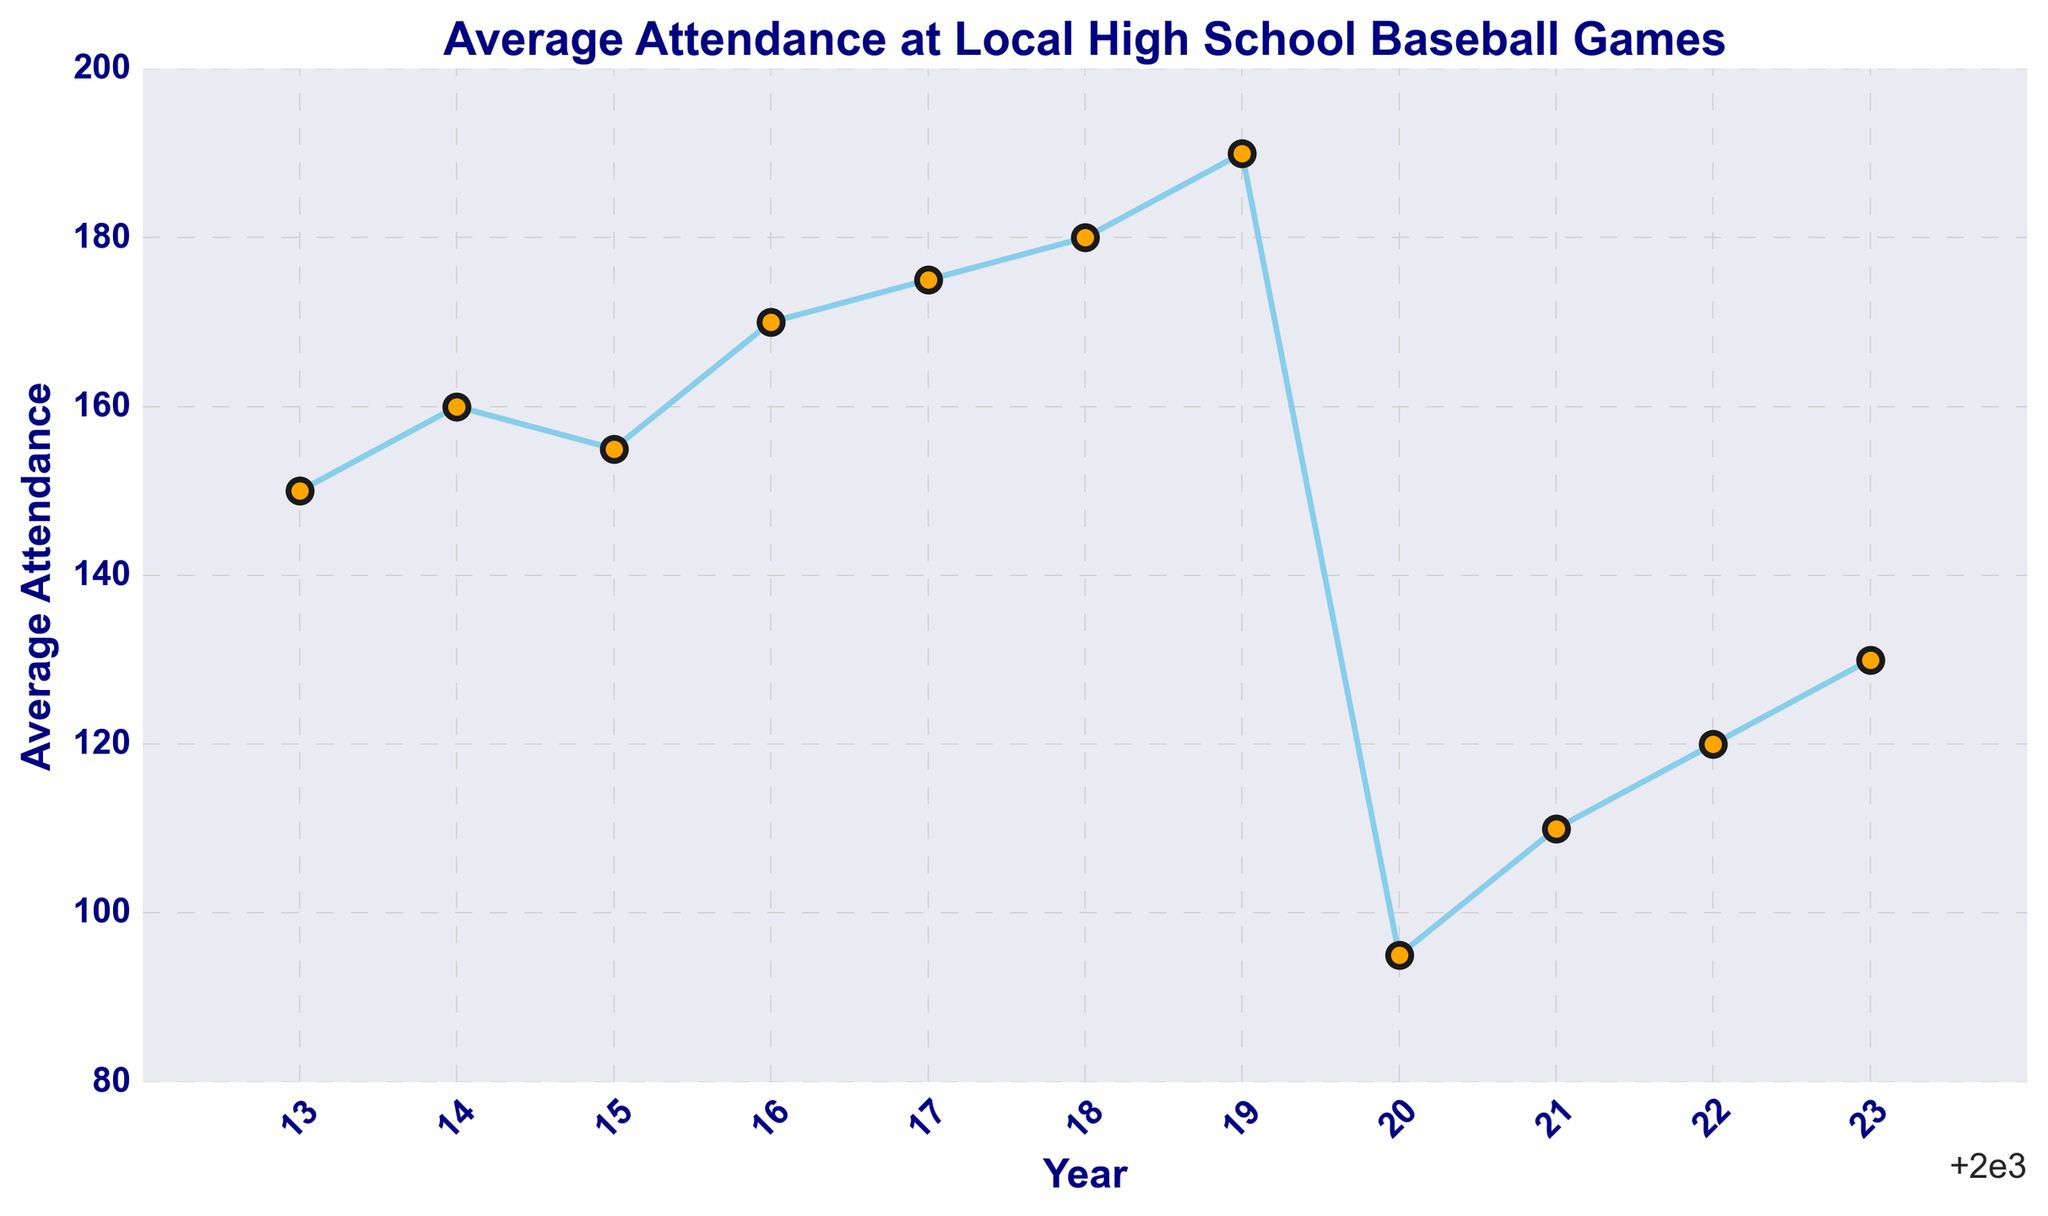What is the highest average attendance over the last 10 years? First, identify the highest point on the line chart. The maximum attendance can be visually seen at 2019, where the value reaches 190.
Answer: 190 Which year had the lowest average attendance? Look for the lowest point on the line chart. The attendance is lowest in 2020, with a value of 95.
Answer: 2020 How much did the average attendance decrease from 2019 to 2020? Locate the average attendance for 2019 and 2020, then subtract the 2020 value from the 2019 value. It goes from 190 in 2019 to 95 in 2020. So, 190 - 95 = 95.
Answer: 95 Did average attendance ever increase for three consecutive years? If so, which years? Look for three continuous increasing segments on the line chart. From 2016 to 2019, the attendance increases continuously: 170 (2016) to 175 (2017) to 180 (2018) to 190 (2019).
Answer: 2016-2019 What is the average attendance across all years shown? Add all the attendance values and divide by the number of years (11 years). (150 + 160 + 155 + 170 + 175 + 180 + 190 + 95 + 110 + 120 + 130) / 11 ≈ 148.18.
Answer: 148.18 Which years had higher average attendance, the first five years or the last five years? Calculate the average for the first and last five years. First five years: (150 + 160 + 155 + 170 + 175) / 5 = 162. Last five years: (95 + 110 + 120 + 130 + 190) / 5 = 129.
Answer: First five years How did the average attendance change from 2021 to 2022? Look at the values for 2021 and 2022 and subtract the 2021 value from the 2022 value. Attendance increased from 110 in 2021 to 120 in 2022, so the change is 120 - 110 = 10.
Answer: Increase by 10 In which year did the average attendance first exceed 150? Find the first year where the value is above 150. In 2014, the attendance was 160, which is the first time it exceeded 150.
Answer: 2014 How many years had an average attendance greater than or equal to 175? Count the number of years where the attendance is 175 or more. The years are 2017 (175), 2018 (180), and 2019 (190). There are three such years.
Answer: 3 What color is used for the markers in the plot? Refer to the description of the plot. The markers have a distinct orange color.
Answer: Orange 